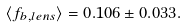<formula> <loc_0><loc_0><loc_500><loc_500>\langle f _ { b , l e n s } \rangle = 0 . 1 0 6 \pm 0 . 0 3 3 .</formula> 